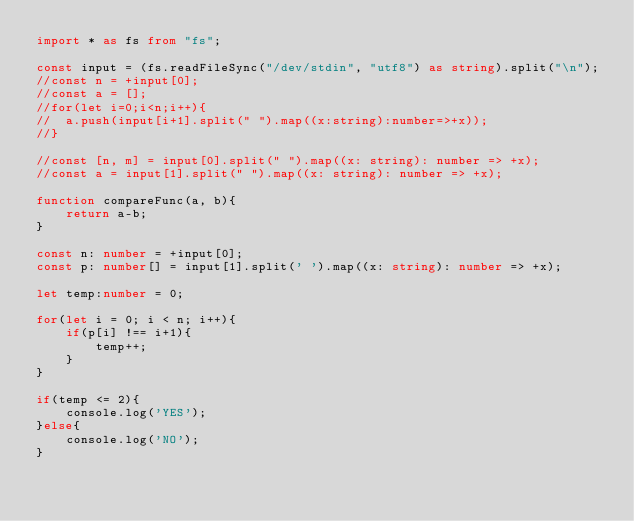<code> <loc_0><loc_0><loc_500><loc_500><_TypeScript_>import * as fs from "fs";

const input = (fs.readFileSync("/dev/stdin", "utf8") as string).split("\n");
//const n = +input[0];
//const a = [];
//for(let i=0;i<n;i++){
//	a.push(input[i+1].split(" ").map((x:string):number=>+x));
//}

//const [n, m] = input[0].split(" ").map((x: string): number => +x);
//const a = input[1].split(" ").map((x: string): number => +x);

function compareFunc(a, b){
    return a-b;
}

const n: number = +input[0];
const p: number[] = input[1].split(' ').map((x: string): number => +x);

let temp:number = 0;

for(let i = 0; i < n; i++){
    if(p[i] !== i+1){
        temp++;
    }
}

if(temp <= 2){
    console.log('YES');
}else{
    console.log('NO');
}</code> 